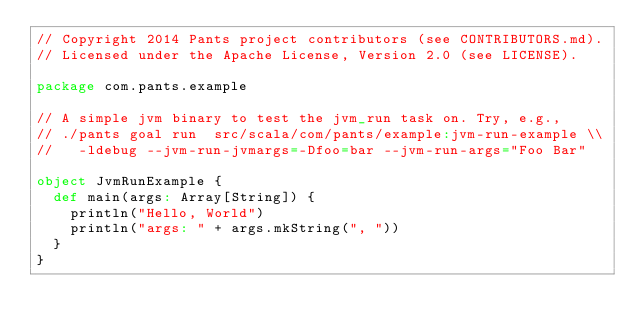<code> <loc_0><loc_0><loc_500><loc_500><_Scala_>// Copyright 2014 Pants project contributors (see CONTRIBUTORS.md).
// Licensed under the Apache License, Version 2.0 (see LICENSE).

package com.pants.example

// A simple jvm binary to test the jvm_run task on. Try, e.g.,
// ./pants goal run  src/scala/com/pants/example:jvm-run-example \\
//   -ldebug --jvm-run-jvmargs=-Dfoo=bar --jvm-run-args="Foo Bar"

object JvmRunExample {
  def main(args: Array[String]) {
    println("Hello, World")
    println("args: " + args.mkString(", "))
  }
}
</code> 